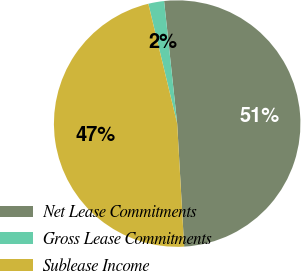<chart> <loc_0><loc_0><loc_500><loc_500><pie_chart><fcel>Net Lease Commitments<fcel>Gross Lease Commitments<fcel>Sublease Income<nl><fcel>50.79%<fcel>2.07%<fcel>47.14%<nl></chart> 